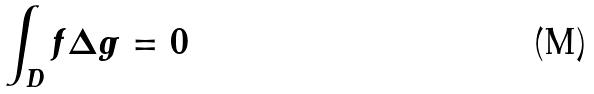<formula> <loc_0><loc_0><loc_500><loc_500>\int _ { D } f \Delta g = 0</formula> 